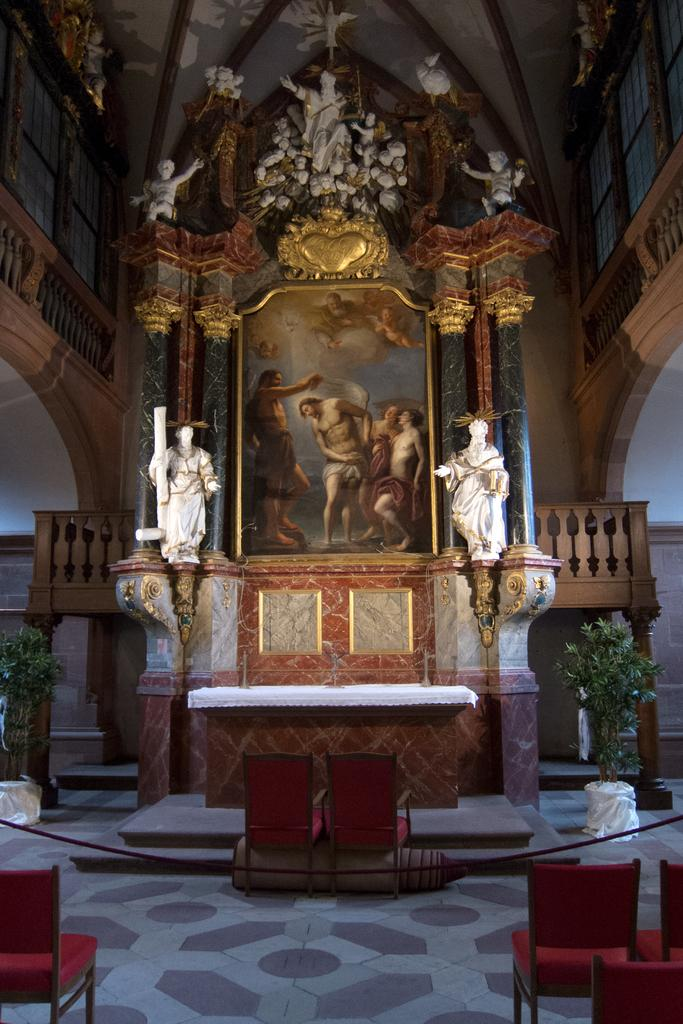What type of furniture is present in the image? There is a table and chairs on the ground in the image. What type of living organism can be seen in the image? There is a plant in the image. What type of decorative item is present in the image? There is a photo frame in the image. What type of art is present in the image? There are sculptures in the image. What type of architectural feature is present in the image? There is a wall in the image. What type of bread can be seen in the image? There is no bread present in the image. What type of letters can be seen in the image? There are no letters visible in the image. 